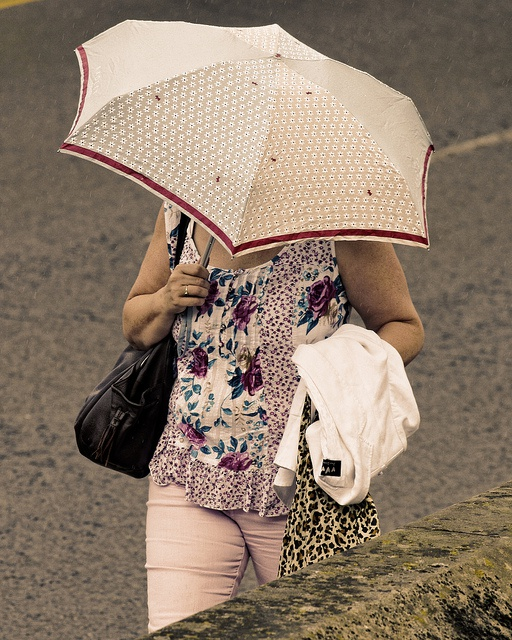Describe the objects in this image and their specific colors. I can see umbrella in olive, lightgray, and tan tones, people in olive, tan, and gray tones, and handbag in olive, black, and gray tones in this image. 